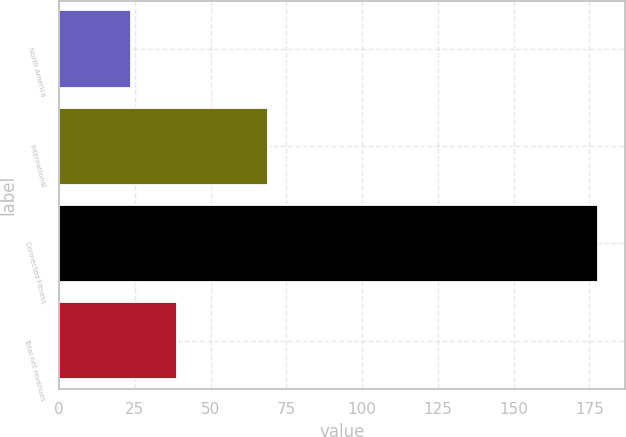Convert chart to OTSL. <chart><loc_0><loc_0><loc_500><loc_500><bar_chart><fcel>North America<fcel>International<fcel>Connected Fitness<fcel>Total net revenues<nl><fcel>23.6<fcel>69<fcel>177.8<fcel>39.02<nl></chart> 